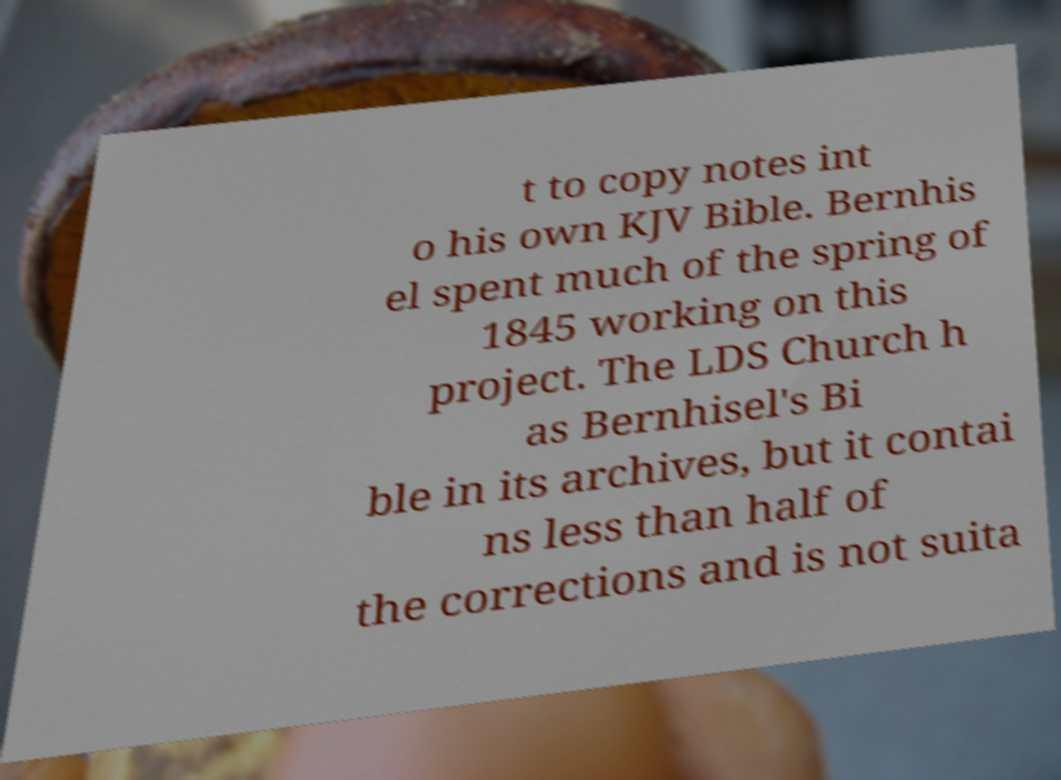I need the written content from this picture converted into text. Can you do that? t to copy notes int o his own KJV Bible. Bernhis el spent much of the spring of 1845 working on this project. The LDS Church h as Bernhisel's Bi ble in its archives, but it contai ns less than half of the corrections and is not suita 